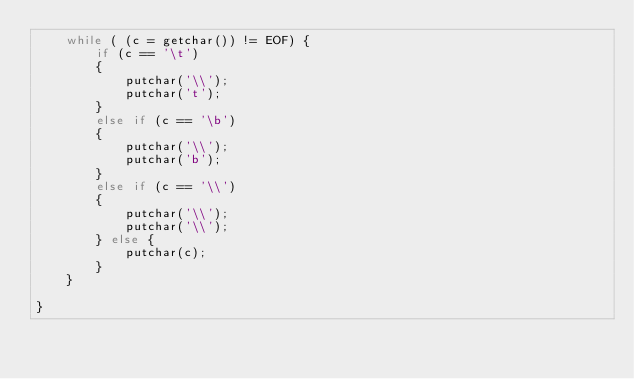<code> <loc_0><loc_0><loc_500><loc_500><_C_>    while ( (c = getchar()) != EOF) {
        if (c == '\t')
        {
            putchar('\\');
            putchar('t');
        }
        else if (c == '\b')
        {
            putchar('\\');
            putchar('b');
        }
        else if (c == '\\')
        {
            putchar('\\');
            putchar('\\');
        } else {
            putchar(c);
        }
    }

}
</code> 